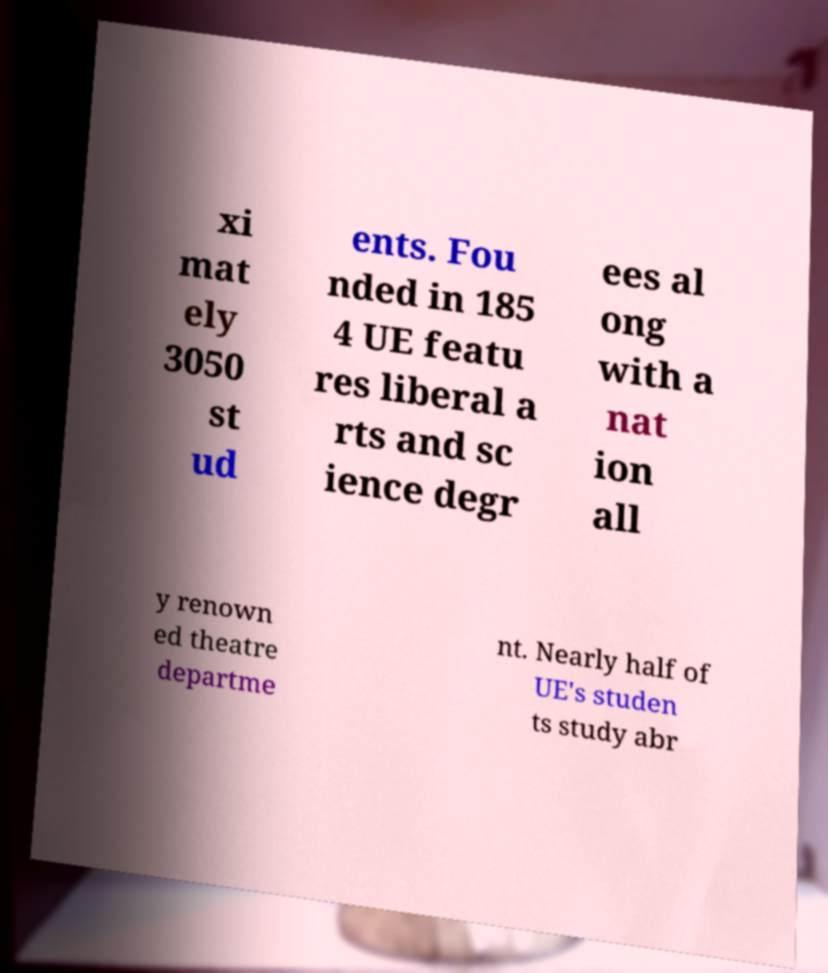Can you accurately transcribe the text from the provided image for me? xi mat ely 3050 st ud ents. Fou nded in 185 4 UE featu res liberal a rts and sc ience degr ees al ong with a nat ion all y renown ed theatre departme nt. Nearly half of UE's studen ts study abr 